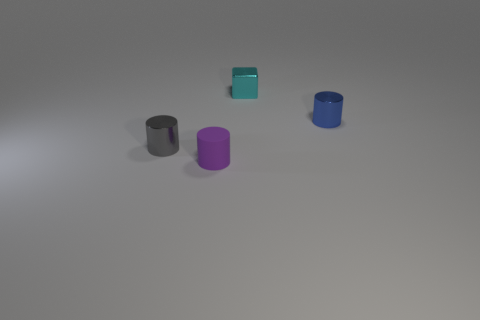What is the material of the blue thing that is the same shape as the small gray metal thing? metal 